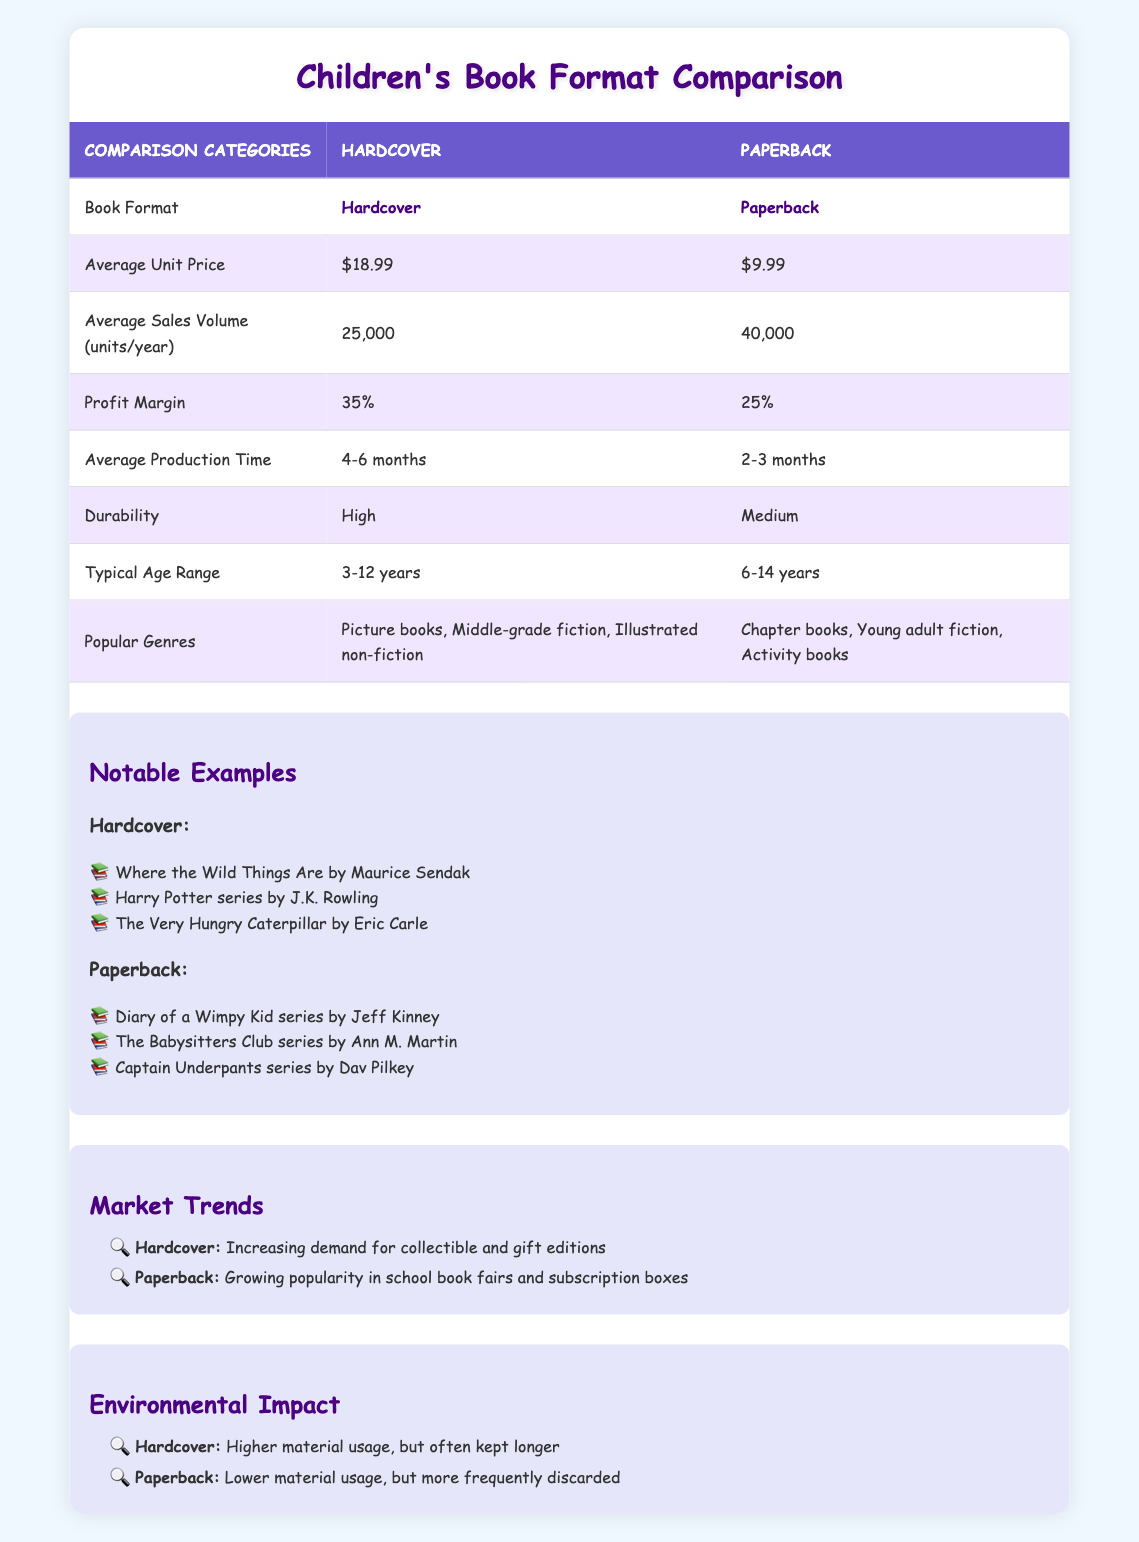What is the average unit price of hardcover children's books? The average unit price of hardcover children's books is listed directly in the table under the "Average Unit Price" row for hardcover. It shows $18.99.
Answer: $18.99 What is the profit margin for paperback books? The profit margin for paperback books is explicitly stated in the table under the "Profit Margin" row for paperback, which shows 25%.
Answer: 25% Which book format has a higher average sales volume per year? The average sales volume per year for hardcover books is 25,000, while for paperback it is 40,000, which is higher. This information is in the "Average Sales Volume (units/year)" row.
Answer: Paperback What is the difference in average production time between hardcover and paperback books? The average production time for hardcover books is 4-6 months, while for paperback books it is 2-3 months. To find the difference, consider the upper limit of hardcover (6 months) and the lower limit of paperback (2 months). This yields a difference of 6 - 2 = 4 months.
Answer: 4 months Are hardcover children's books typically targeted at a younger age range than paperback books? The typical age range listed for hardcover books is 3-12 years, while for paperback books it is 6-14 years. Since the lower end of the age range for hardcover (3 years) is younger than that of paperback (6 years), the statement is true.
Answer: Yes What popular genre is unique to hardcover books? By examining the table under the "Popular Genres" row, the genres listed for hardcover books include picture books and illustrated non-fiction, which are not mentioned for paperback. Thus, picture books can be identified as unique to hardcover.
Answer: Picture books Calculate the total average sales volume for both hardcover and paperback books combined. The total average sales volume is found by adding the average sales volumes for both formats: 25,000 (hardcover) + 40,000 (paperback) = 65,000 units/year.
Answer: 65,000 units/year Which book format has a lower environmental impact in terms of material usage? The table states that paperback books have lower material usage, while hardcover books have higher material usage. Thus, the statement that paperback has a lower environmental impact in terms of material usage is true.
Answer: Yes What trend is noted for hardcover and paperback books in market trends? The market trends section specifies that hardcover books are seeing an increasing demand for collectible and gift editions, while paperback books are becoming more popular in school book fairs and subscription boxes. Both trends highlight their growing niches.
Answer: Collectible and gift editions; school fairs and subscription boxes 